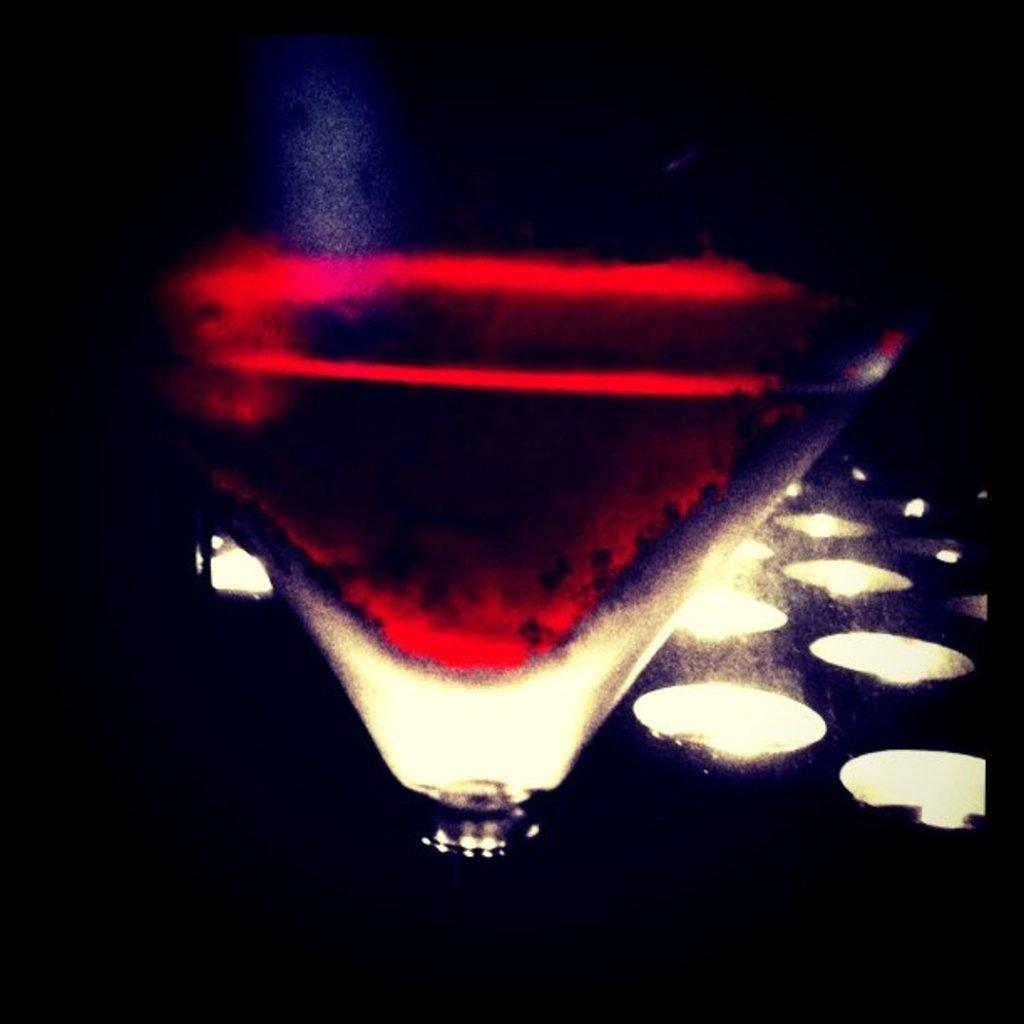What is the main object in the center of the image? There is a glass in the center of the image. What can be seen in the background of the image? There are lights in the background area of the image. What type of muscle is being flexed by the grandfather in the image? There is no grandfather or muscle flexing present in the image; it only features a glass and lights in the background. 